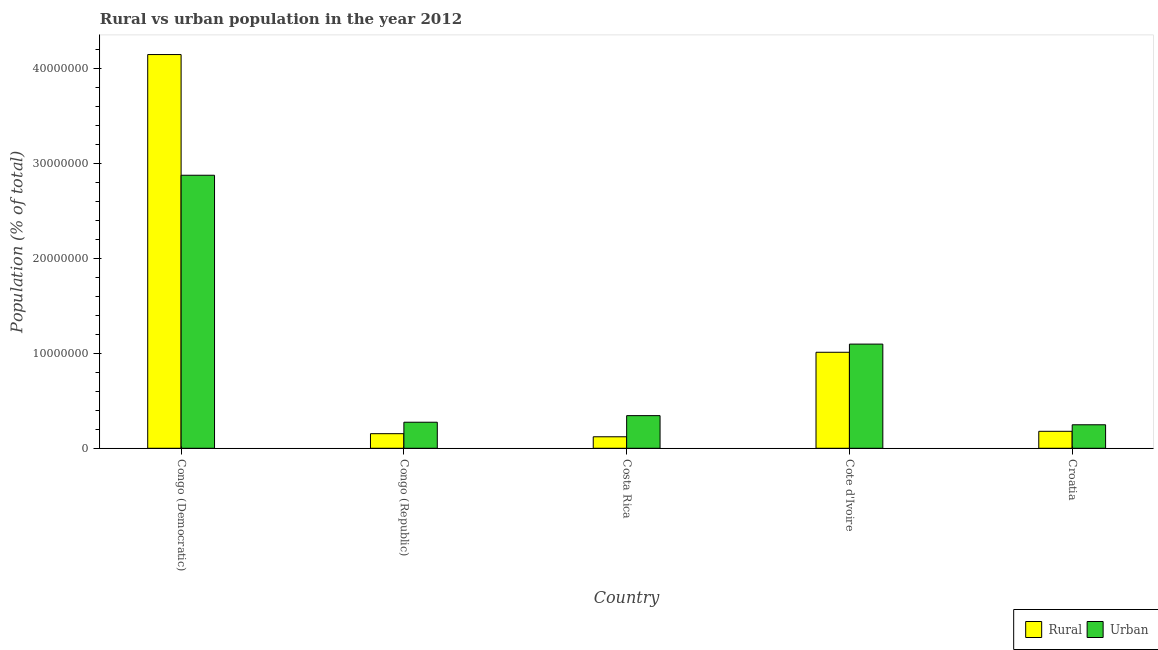How many groups of bars are there?
Give a very brief answer. 5. What is the label of the 4th group of bars from the left?
Make the answer very short. Cote d'Ivoire. What is the rural population density in Croatia?
Your response must be concise. 1.79e+06. Across all countries, what is the maximum rural population density?
Make the answer very short. 4.15e+07. Across all countries, what is the minimum urban population density?
Provide a succinct answer. 2.48e+06. In which country was the urban population density maximum?
Provide a succinct answer. Congo (Democratic). In which country was the urban population density minimum?
Your answer should be very brief. Croatia. What is the total rural population density in the graph?
Make the answer very short. 5.62e+07. What is the difference between the rural population density in Cote d'Ivoire and that in Croatia?
Ensure brevity in your answer.  8.33e+06. What is the difference between the rural population density in Congo (Republic) and the urban population density in Croatia?
Give a very brief answer. -9.40e+05. What is the average urban population density per country?
Provide a succinct answer. 9.69e+06. What is the difference between the rural population density and urban population density in Costa Rica?
Ensure brevity in your answer.  -2.23e+06. In how many countries, is the urban population density greater than 40000000 %?
Give a very brief answer. 0. What is the ratio of the rural population density in Congo (Republic) to that in Cote d'Ivoire?
Offer a terse response. 0.15. Is the urban population density in Congo (Democratic) less than that in Croatia?
Your response must be concise. No. What is the difference between the highest and the second highest rural population density?
Offer a very short reply. 3.14e+07. What is the difference between the highest and the lowest urban population density?
Ensure brevity in your answer.  2.63e+07. Is the sum of the urban population density in Costa Rica and Cote d'Ivoire greater than the maximum rural population density across all countries?
Provide a short and direct response. No. What does the 1st bar from the left in Cote d'Ivoire represents?
Make the answer very short. Rural. What does the 2nd bar from the right in Congo (Democratic) represents?
Your answer should be very brief. Rural. Are all the bars in the graph horizontal?
Provide a short and direct response. No. How many countries are there in the graph?
Your answer should be very brief. 5. How are the legend labels stacked?
Give a very brief answer. Horizontal. What is the title of the graph?
Offer a very short reply. Rural vs urban population in the year 2012. Does "Transport services" appear as one of the legend labels in the graph?
Your answer should be compact. No. What is the label or title of the Y-axis?
Your answer should be very brief. Population (% of total). What is the Population (% of total) in Rural in Congo (Democratic)?
Offer a very short reply. 4.15e+07. What is the Population (% of total) in Urban in Congo (Democratic)?
Your response must be concise. 2.88e+07. What is the Population (% of total) of Rural in Congo (Republic)?
Your answer should be compact. 1.54e+06. What is the Population (% of total) in Urban in Congo (Republic)?
Give a very brief answer. 2.75e+06. What is the Population (% of total) of Rural in Costa Rica?
Make the answer very short. 1.21e+06. What is the Population (% of total) in Urban in Costa Rica?
Offer a very short reply. 3.44e+06. What is the Population (% of total) in Rural in Cote d'Ivoire?
Your answer should be very brief. 1.01e+07. What is the Population (% of total) in Urban in Cote d'Ivoire?
Your answer should be very brief. 1.10e+07. What is the Population (% of total) in Rural in Croatia?
Make the answer very short. 1.79e+06. What is the Population (% of total) of Urban in Croatia?
Make the answer very short. 2.48e+06. Across all countries, what is the maximum Population (% of total) of Rural?
Offer a terse response. 4.15e+07. Across all countries, what is the maximum Population (% of total) in Urban?
Your answer should be compact. 2.88e+07. Across all countries, what is the minimum Population (% of total) in Rural?
Give a very brief answer. 1.21e+06. Across all countries, what is the minimum Population (% of total) of Urban?
Keep it short and to the point. 2.48e+06. What is the total Population (% of total) in Rural in the graph?
Your answer should be very brief. 5.62e+07. What is the total Population (% of total) of Urban in the graph?
Ensure brevity in your answer.  4.84e+07. What is the difference between the Population (% of total) in Rural in Congo (Democratic) and that in Congo (Republic)?
Your answer should be very brief. 4.00e+07. What is the difference between the Population (% of total) in Urban in Congo (Democratic) and that in Congo (Republic)?
Give a very brief answer. 2.60e+07. What is the difference between the Population (% of total) of Rural in Congo (Democratic) and that in Costa Rica?
Provide a succinct answer. 4.03e+07. What is the difference between the Population (% of total) in Urban in Congo (Democratic) and that in Costa Rica?
Your answer should be very brief. 2.53e+07. What is the difference between the Population (% of total) in Rural in Congo (Democratic) and that in Cote d'Ivoire?
Provide a succinct answer. 3.14e+07. What is the difference between the Population (% of total) of Urban in Congo (Democratic) and that in Cote d'Ivoire?
Give a very brief answer. 1.78e+07. What is the difference between the Population (% of total) in Rural in Congo (Democratic) and that in Croatia?
Offer a very short reply. 3.97e+07. What is the difference between the Population (% of total) in Urban in Congo (Democratic) and that in Croatia?
Offer a very short reply. 2.63e+07. What is the difference between the Population (% of total) of Rural in Congo (Republic) and that in Costa Rica?
Provide a succinct answer. 3.26e+05. What is the difference between the Population (% of total) of Urban in Congo (Republic) and that in Costa Rica?
Ensure brevity in your answer.  -6.94e+05. What is the difference between the Population (% of total) of Rural in Congo (Republic) and that in Cote d'Ivoire?
Give a very brief answer. -8.58e+06. What is the difference between the Population (% of total) of Urban in Congo (Republic) and that in Cote d'Ivoire?
Offer a very short reply. -8.23e+06. What is the difference between the Population (% of total) in Rural in Congo (Republic) and that in Croatia?
Keep it short and to the point. -2.50e+05. What is the difference between the Population (% of total) in Urban in Congo (Republic) and that in Croatia?
Ensure brevity in your answer.  2.69e+05. What is the difference between the Population (% of total) of Rural in Costa Rica and that in Cote d'Ivoire?
Offer a very short reply. -8.91e+06. What is the difference between the Population (% of total) in Urban in Costa Rica and that in Cote d'Ivoire?
Offer a very short reply. -7.54e+06. What is the difference between the Population (% of total) in Rural in Costa Rica and that in Croatia?
Your answer should be compact. -5.76e+05. What is the difference between the Population (% of total) of Urban in Costa Rica and that in Croatia?
Your answer should be compact. 9.63e+05. What is the difference between the Population (% of total) in Rural in Cote d'Ivoire and that in Croatia?
Ensure brevity in your answer.  8.33e+06. What is the difference between the Population (% of total) in Urban in Cote d'Ivoire and that in Croatia?
Give a very brief answer. 8.50e+06. What is the difference between the Population (% of total) in Rural in Congo (Democratic) and the Population (% of total) in Urban in Congo (Republic)?
Make the answer very short. 3.88e+07. What is the difference between the Population (% of total) in Rural in Congo (Democratic) and the Population (% of total) in Urban in Costa Rica?
Your answer should be very brief. 3.81e+07. What is the difference between the Population (% of total) of Rural in Congo (Democratic) and the Population (% of total) of Urban in Cote d'Ivoire?
Keep it short and to the point. 3.05e+07. What is the difference between the Population (% of total) of Rural in Congo (Democratic) and the Population (% of total) of Urban in Croatia?
Keep it short and to the point. 3.90e+07. What is the difference between the Population (% of total) in Rural in Congo (Republic) and the Population (% of total) in Urban in Costa Rica?
Provide a succinct answer. -1.90e+06. What is the difference between the Population (% of total) in Rural in Congo (Republic) and the Population (% of total) in Urban in Cote d'Ivoire?
Your answer should be compact. -9.44e+06. What is the difference between the Population (% of total) of Rural in Congo (Republic) and the Population (% of total) of Urban in Croatia?
Your answer should be very brief. -9.40e+05. What is the difference between the Population (% of total) in Rural in Costa Rica and the Population (% of total) in Urban in Cote d'Ivoire?
Provide a short and direct response. -9.77e+06. What is the difference between the Population (% of total) of Rural in Costa Rica and the Population (% of total) of Urban in Croatia?
Give a very brief answer. -1.27e+06. What is the difference between the Population (% of total) of Rural in Cote d'Ivoire and the Population (% of total) of Urban in Croatia?
Your response must be concise. 7.64e+06. What is the average Population (% of total) in Rural per country?
Make the answer very short. 1.12e+07. What is the average Population (% of total) of Urban per country?
Your answer should be compact. 9.69e+06. What is the difference between the Population (% of total) in Rural and Population (% of total) in Urban in Congo (Democratic)?
Provide a short and direct response. 1.27e+07. What is the difference between the Population (% of total) of Rural and Population (% of total) of Urban in Congo (Republic)?
Your answer should be very brief. -1.21e+06. What is the difference between the Population (% of total) of Rural and Population (% of total) of Urban in Costa Rica?
Ensure brevity in your answer.  -2.23e+06. What is the difference between the Population (% of total) in Rural and Population (% of total) in Urban in Cote d'Ivoire?
Provide a succinct answer. -8.61e+05. What is the difference between the Population (% of total) of Rural and Population (% of total) of Urban in Croatia?
Your answer should be compact. -6.89e+05. What is the ratio of the Population (% of total) in Rural in Congo (Democratic) to that in Congo (Republic)?
Your answer should be very brief. 26.97. What is the ratio of the Population (% of total) of Urban in Congo (Democratic) to that in Congo (Republic)?
Give a very brief answer. 10.48. What is the ratio of the Population (% of total) of Rural in Congo (Democratic) to that in Costa Rica?
Your answer should be very brief. 34.22. What is the ratio of the Population (% of total) of Urban in Congo (Democratic) to that in Costa Rica?
Make the answer very short. 8.36. What is the ratio of the Population (% of total) in Rural in Congo (Democratic) to that in Cote d'Ivoire?
Ensure brevity in your answer.  4.1. What is the ratio of the Population (% of total) in Urban in Congo (Democratic) to that in Cote d'Ivoire?
Ensure brevity in your answer.  2.62. What is the ratio of the Population (% of total) in Rural in Congo (Democratic) to that in Croatia?
Give a very brief answer. 23.2. What is the ratio of the Population (% of total) of Urban in Congo (Democratic) to that in Croatia?
Make the answer very short. 11.61. What is the ratio of the Population (% of total) of Rural in Congo (Republic) to that in Costa Rica?
Keep it short and to the point. 1.27. What is the ratio of the Population (% of total) in Urban in Congo (Republic) to that in Costa Rica?
Give a very brief answer. 0.8. What is the ratio of the Population (% of total) in Rural in Congo (Republic) to that in Cote d'Ivoire?
Ensure brevity in your answer.  0.15. What is the ratio of the Population (% of total) of Urban in Congo (Republic) to that in Cote d'Ivoire?
Make the answer very short. 0.25. What is the ratio of the Population (% of total) in Rural in Congo (Republic) to that in Croatia?
Give a very brief answer. 0.86. What is the ratio of the Population (% of total) in Urban in Congo (Republic) to that in Croatia?
Provide a short and direct response. 1.11. What is the ratio of the Population (% of total) of Rural in Costa Rica to that in Cote d'Ivoire?
Provide a succinct answer. 0.12. What is the ratio of the Population (% of total) of Urban in Costa Rica to that in Cote d'Ivoire?
Your answer should be very brief. 0.31. What is the ratio of the Population (% of total) of Rural in Costa Rica to that in Croatia?
Give a very brief answer. 0.68. What is the ratio of the Population (% of total) in Urban in Costa Rica to that in Croatia?
Make the answer very short. 1.39. What is the ratio of the Population (% of total) of Rural in Cote d'Ivoire to that in Croatia?
Provide a succinct answer. 5.66. What is the ratio of the Population (% of total) in Urban in Cote d'Ivoire to that in Croatia?
Offer a very short reply. 4.43. What is the difference between the highest and the second highest Population (% of total) of Rural?
Offer a very short reply. 3.14e+07. What is the difference between the highest and the second highest Population (% of total) in Urban?
Provide a succinct answer. 1.78e+07. What is the difference between the highest and the lowest Population (% of total) of Rural?
Provide a succinct answer. 4.03e+07. What is the difference between the highest and the lowest Population (% of total) in Urban?
Provide a succinct answer. 2.63e+07. 